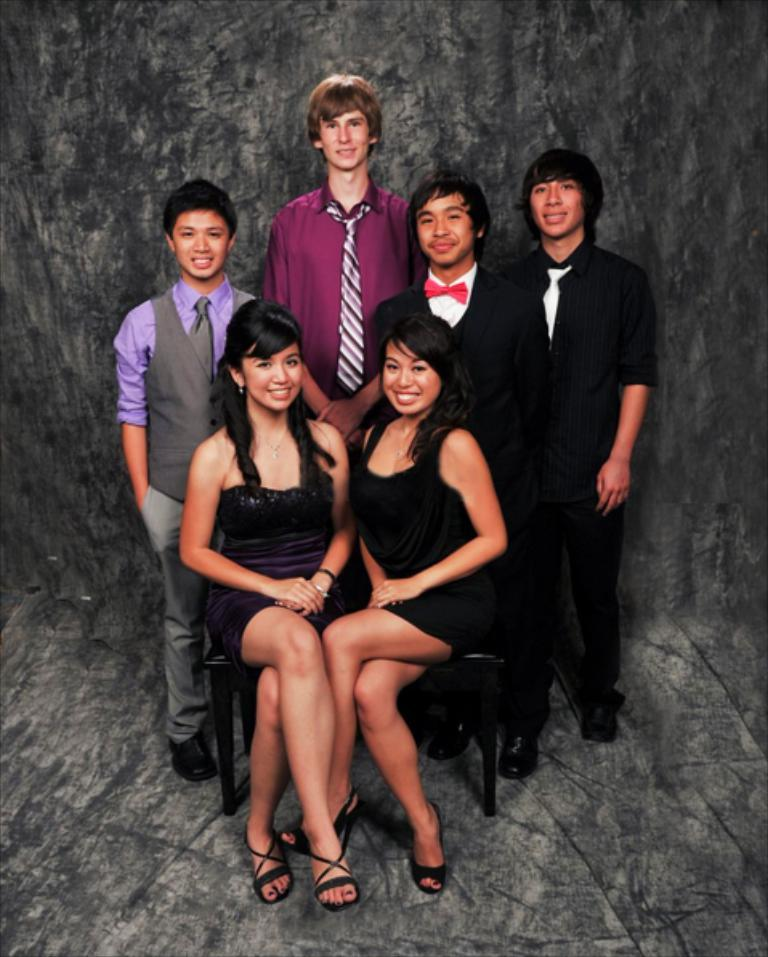What is the main subject of the image? The main subject of the image is a group of people. How are the people dressed in the image? The people are wearing different color dresses in the image. What are two people in the image doing? Two people in the image are sitting on chairs. What can be seen in the background of the image? There is a grey color wall in the background of the image. What type of steel structure can be seen in the image? There is no steel structure present in the image; it features a group of people and a grey wall in the background. How does the digestion process of the people in the image appear to be? There is no information about the digestion process of the people in the image, as it focuses on their clothing and actions. 